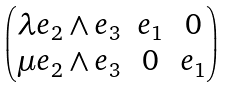<formula> <loc_0><loc_0><loc_500><loc_500>\begin{pmatrix} \lambda e _ { 2 } \wedge e _ { 3 } & e _ { 1 } & 0 \\ \mu e _ { 2 } \wedge e _ { 3 } & 0 & e _ { 1 } \end{pmatrix}</formula> 